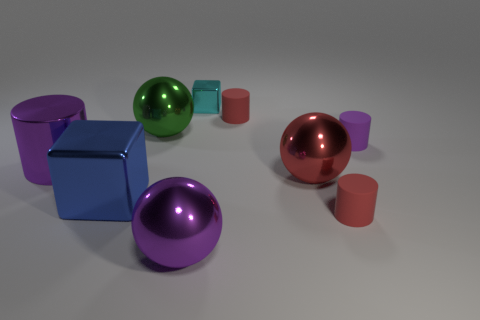Subtract all small cylinders. How many cylinders are left? 1 Add 1 tiny red objects. How many objects exist? 10 Subtract all brown cylinders. Subtract all red blocks. How many cylinders are left? 4 Subtract all blocks. How many objects are left? 7 Add 9 red shiny balls. How many red shiny balls exist? 10 Subtract 0 gray blocks. How many objects are left? 9 Subtract all big red objects. Subtract all small metallic objects. How many objects are left? 7 Add 8 big red balls. How many big red balls are left? 9 